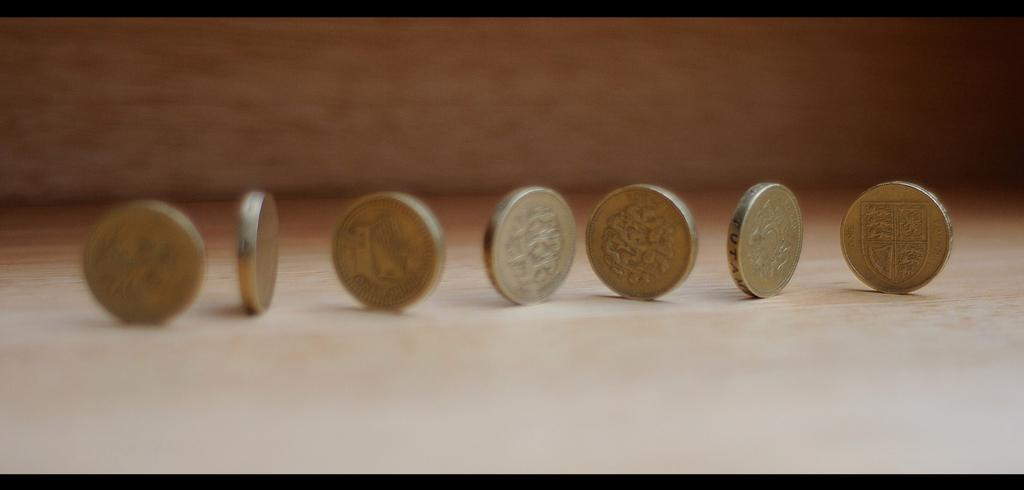What objects are on the platform in the image? There are coins on a platform in the image. Can you describe the background of the image? The background of the image is blurry. Where is the stove located in the image? There is no stove present in the image. What type of hydrant can be seen in the image? There is no hydrant present in the image. 